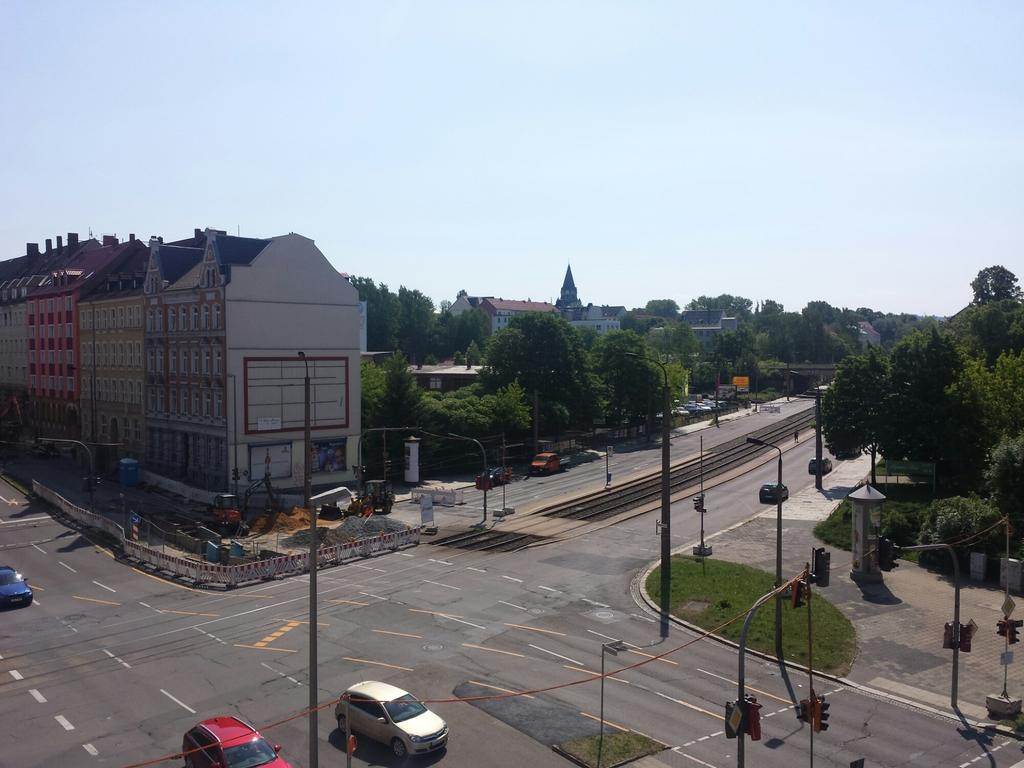What type of vehicles can be seen in the image? There are cars in the image. What type of infrastructure is present in the image? There are roads, traffic lights, lamp posts, sign boards, telephone booths, and fences in the image. What type of terrain is visible in the image? There is sand, concrete, stones, and trees in the image. What type of structures are present in the image? There are buildings in the image. Can you see any clams in the image? There are no clams present in the image. What color is the sea in the image? There is no sea present in the image. 